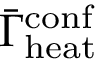<formula> <loc_0><loc_0><loc_500><loc_500>\bar { \Gamma } _ { h e a t } ^ { c o n f }</formula> 